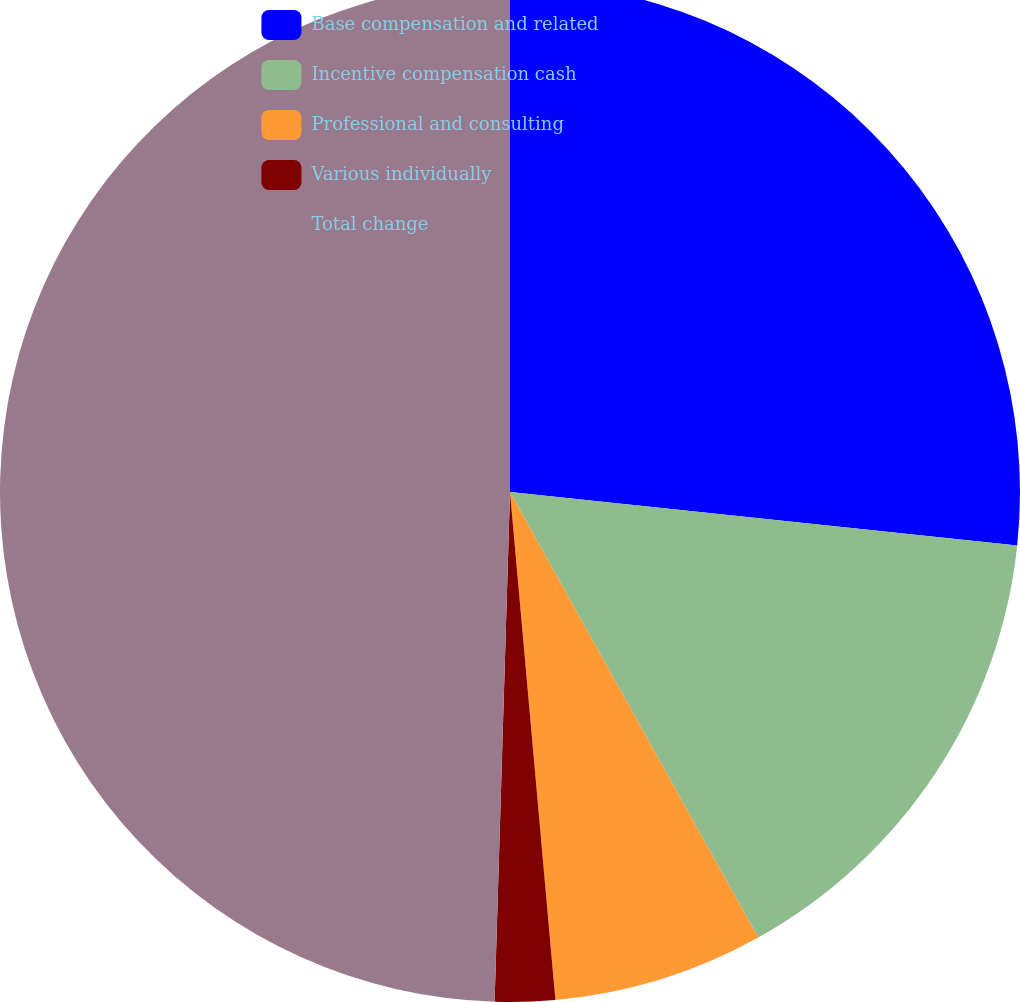Convert chart. <chart><loc_0><loc_0><loc_500><loc_500><pie_chart><fcel>Base compensation and related<fcel>Incentive compensation cash<fcel>Professional and consulting<fcel>Various individually<fcel>Total change<nl><fcel>26.67%<fcel>15.24%<fcel>6.67%<fcel>1.9%<fcel>49.52%<nl></chart> 